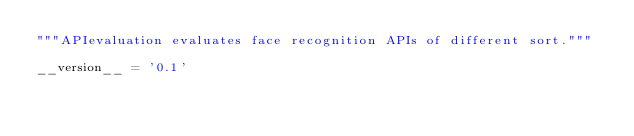Convert code to text. <code><loc_0><loc_0><loc_500><loc_500><_Python_>"""APIevaluation evaluates face recognition APIs of different sort."""

__version__ = '0.1'
</code> 